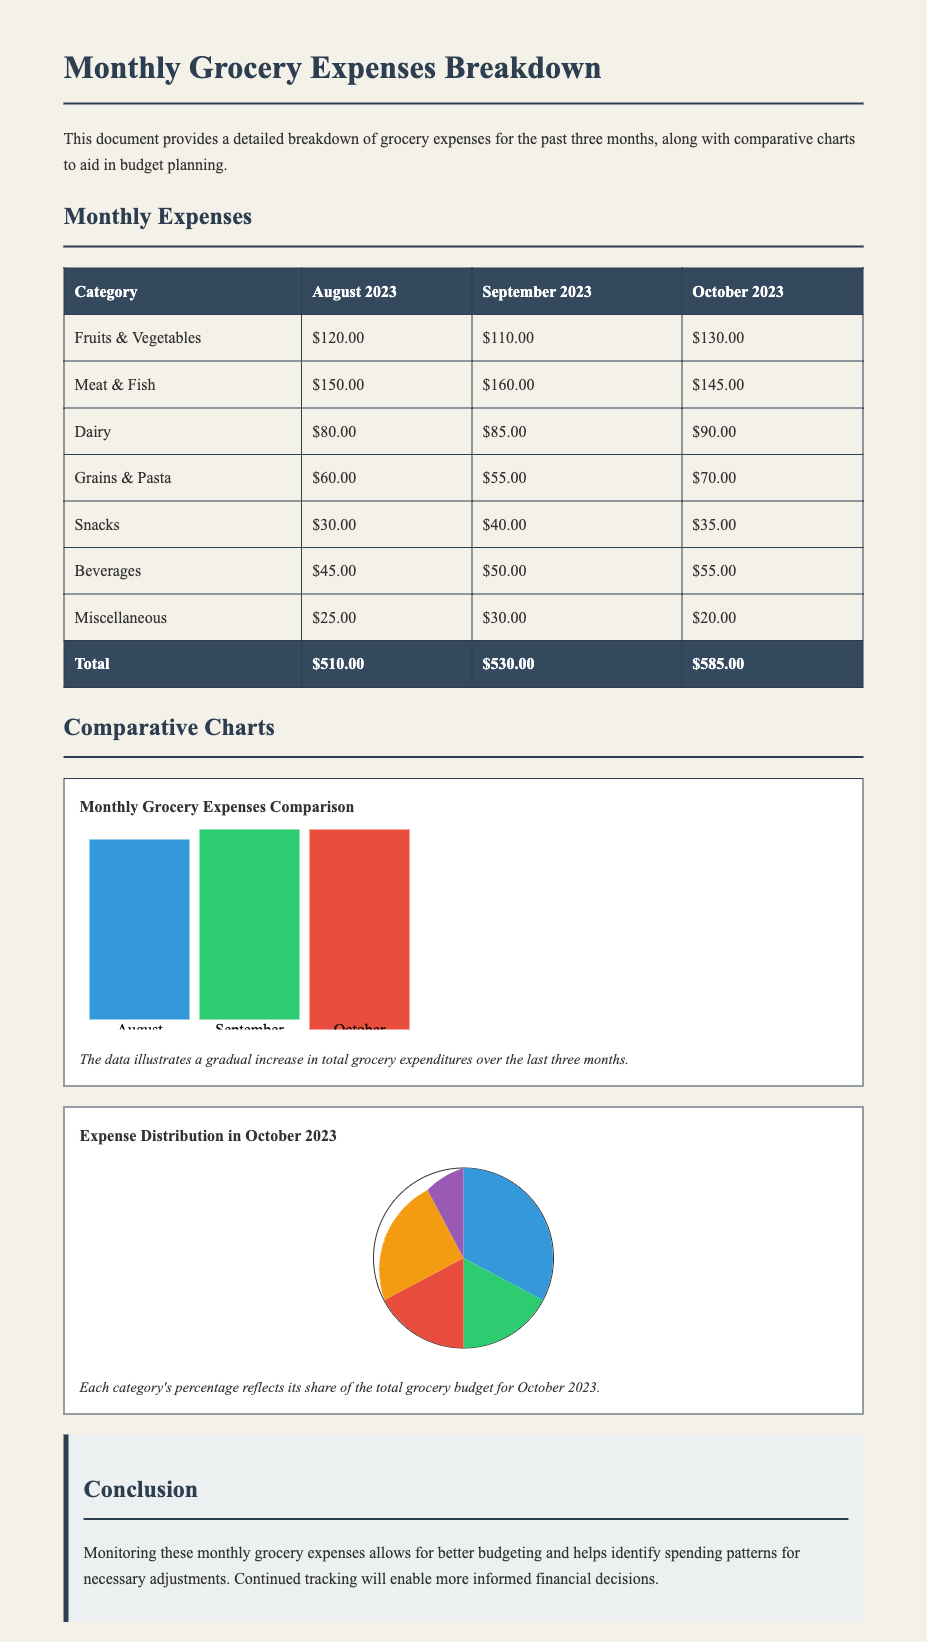What was the total grocery expense in September 2023? The total grocery expense for September 2023 is listed in the table as $530.00.
Answer: $530.00 Which category had the highest expense in October 2023? The highest expense category in October 2023 was Meat & Fish, as per the table showing individual category expenses.
Answer: Meat & Fish How much was spent on Snacks in August 2023? The table indicates that the expense for Snacks in August 2023 was $30.00.
Answer: $30.00 What is the percentage increase in total expenses from August to October 2023? The total expense increased from $510.00 in August to $585.00 in October, showing an increase of $75.00. Calculation of percentage increase gives: (75 / 510) * 100 = 14.71%.
Answer: 14.71% What was the total expense on Dairy over the three months? The total expense on Dairy can be calculated by adding the amounts for each month: $80.00 + $85.00 + $90.00 = $255.00.
Answer: $255.00 Which month had the lowest total grocery expense? By comparing the total expenses listed in the document, August 2023 has the lowest expense of $510.00.
Answer: August 2023 What does the chart on expense distribution represent? The chart illustrates the share of each grocery category's expense in October 2023 relative to the total grocery budget for that month.
Answer: Expense distribution What color represents Beverages in the comparative chart? In the November chart, Beverages are represented by the color green.
Answer: Green 